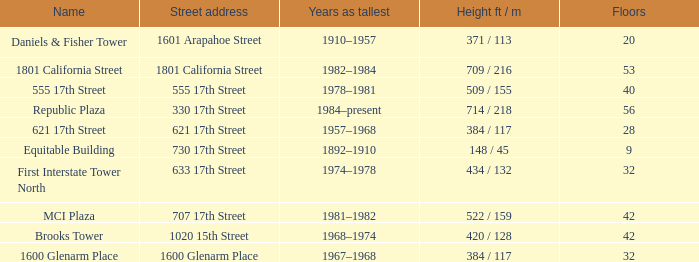What is the height of the building with 40 floors? 509 / 155. 